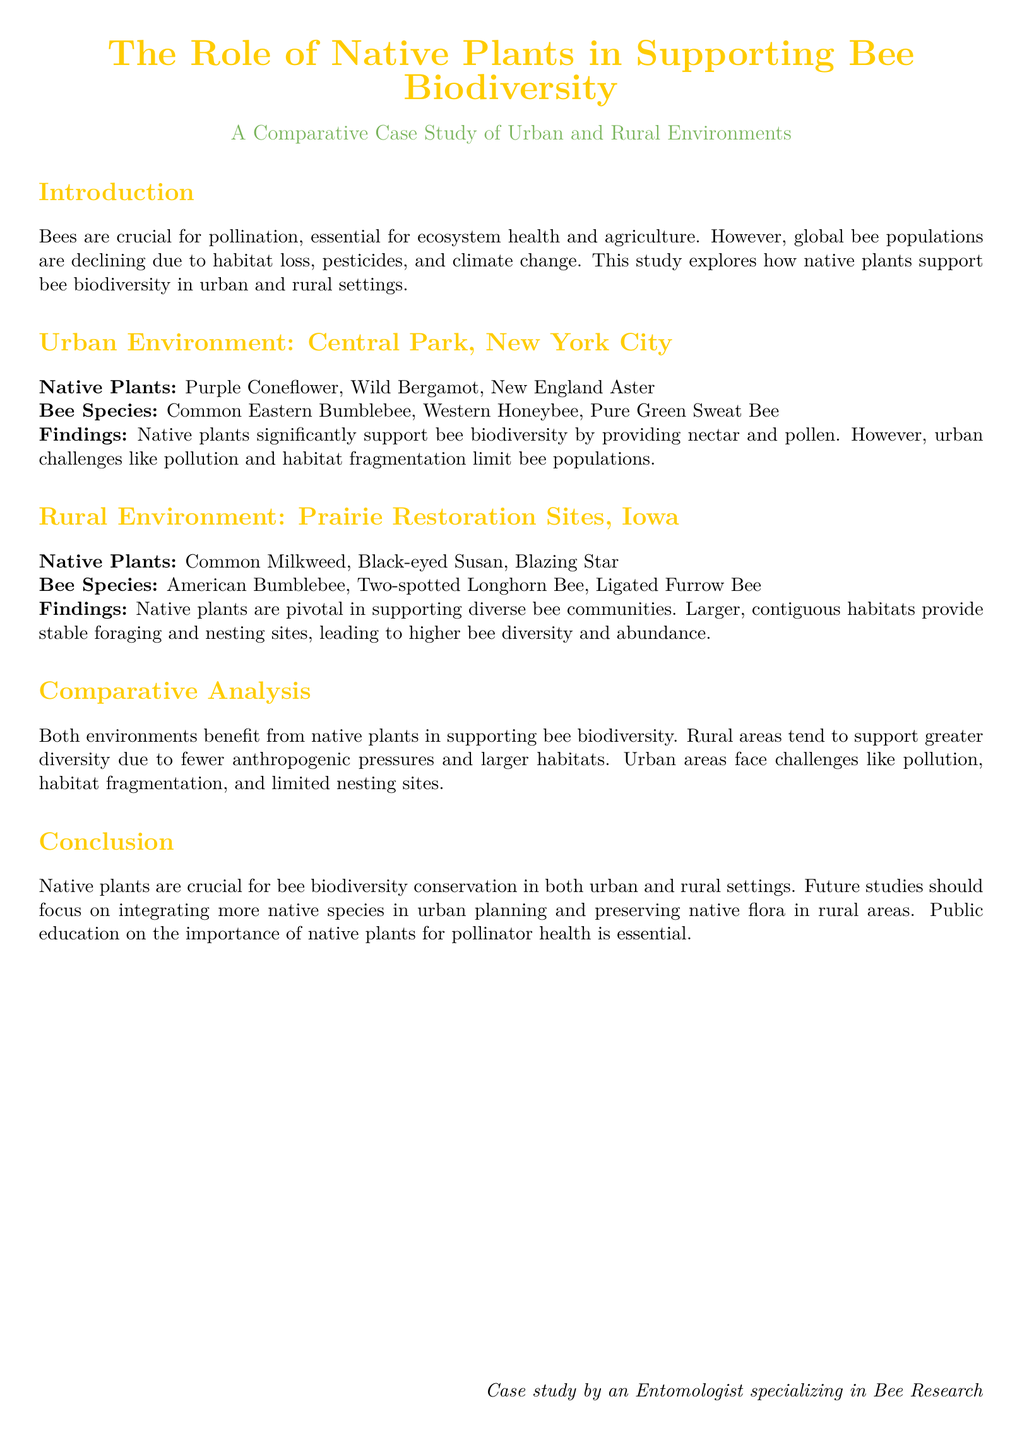What is the main focus of the study? The study focuses on how native plants support bee biodiversity in urban and rural settings.
Answer: Native plants supporting bee biodiversity What are the native plants listed for the urban environment? The native plants for the urban environment are specified in the document as part of the Central Park case study.
Answer: Purple Coneflower, Wild Bergamot, New England Aster Which bee species is found in rural Iowa environments? The document lists several bee species found in Prairie Restoration Sites, which are rural environments.
Answer: American Bumblebee, Two-spotted Longhorn Bee, Ligated Furrow Bee What is a key finding regarding urban areas? The findings for urban areas include challenges that affect bee populations, as stated in the Comparative Analysis section.
Answer: Pollution and habitat fragmentation How do rural habitats support bee diversity? The findings in the rural environment section indicate how larger habitats benefit bee communities.
Answer: Larger, contiguous habitats What recommendations does the conclusion provide for urban planning? The conclusion section suggests future actions for public and environmental planning as it pertains to native plants.
Answer: Integrating more native species What are the primary anthropogenic pressures in urban environments according to the document? The document describes specific challenges experienced in urban areas that limit bee populations.
Answer: Pollution, habitat fragmentation Which environment supports greater bee diversity? The Comparative Analysis section makes a direct comparison between urban and rural environments regarding diversity.
Answer: Rural environments What is the significance of public education according to the conclusion? The conclusion emphasizes a particular aspect regarding community involvement and understanding of native plants.
Answer: Importance of native plants for pollinator health 